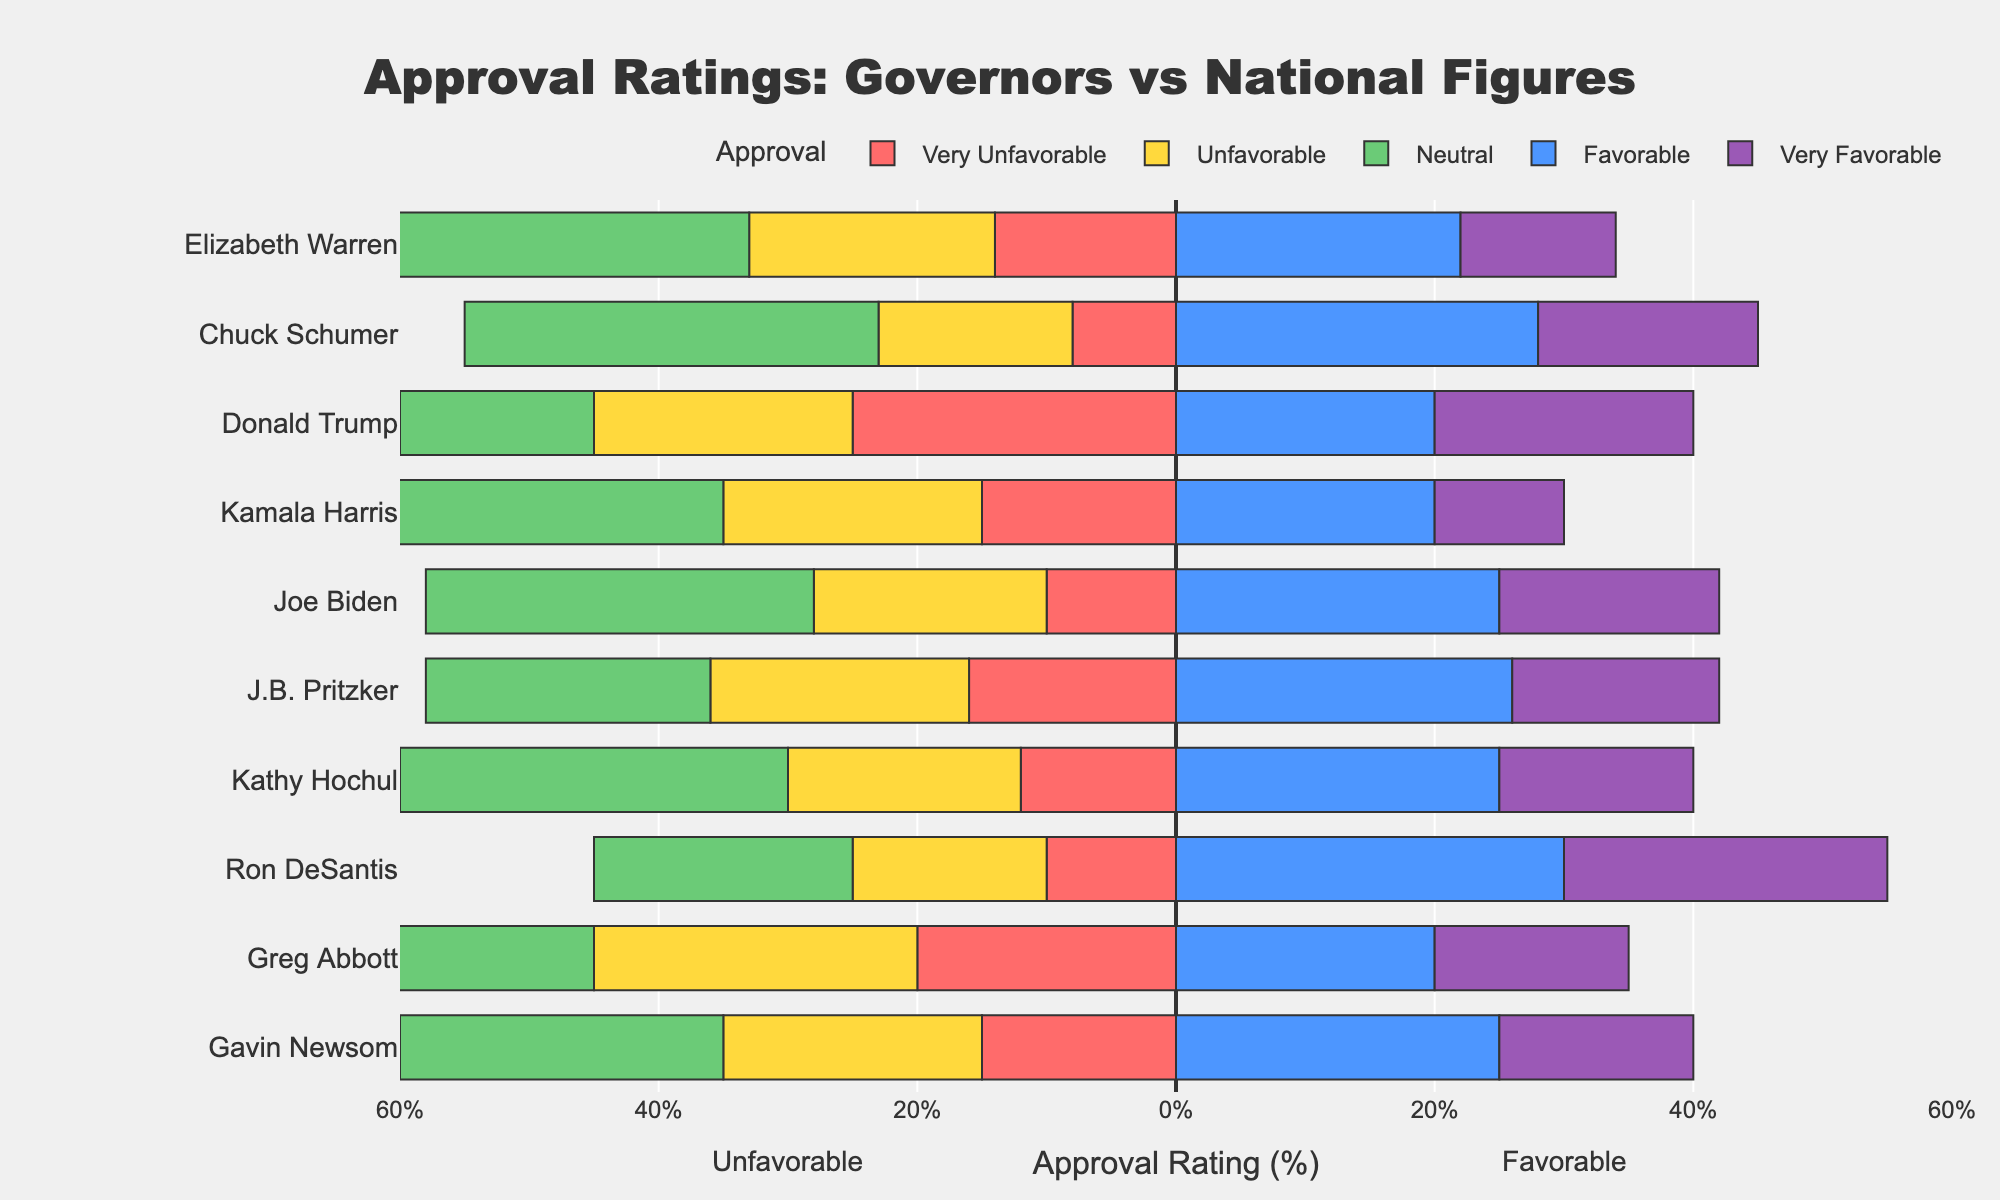What is the difference in the percentage of very favorable approvals between Gavin Newsom and Joe Biden? Gavin Newsom has a very favorable approval rating of 15%, while Joe Biden has a very favorable approval rating of 17%. The difference is calculated as 17% - 15%.
Answer: 2% Which governor has the highest unfavorable approval rating? By comparing all the governors' unfavorable approval ratings, Greg Abbott has an unfavorable rating of 25%, which is the highest among the governors listed.
Answer: Greg Abbott For Ron DeSantis, what is the total percentage of combined favorable (favorable + very favorable) approvals? How does it compare to Donald Trump's combined favorable approvals? Ron DeSantis has favorable and very favorable ratings at 30% and 25%, respectively, summing up to 30 + 25 = 55%. Donald Trump has 20% favorable and 20% very favorable, summing up to 20 + 20 = 40%. Therefore, Ron DeSantis has 15% more combined favorable approvals than Donald Trump.
Answer: 55% for Ron DeSantis, 15% more than Donald Trump What is the neutral approval rating for Kamala Harris, and how does it compare to Greg Abbott's neutral rating? Kamala Harris has a neutral rating of 35%, while Greg Abbott has a neutral rating of 20%. The difference between them is 35% - 20%.
Answer: 15% higher for Kamala Harris Between Kathy Hochul and Elizabeth Warren, who has the higher total of very unfavorable and unfavorable approval ratings, and by how much? Kathy Hochul's very unfavorable and unfavorable ratings are 12% and 18%, respectively, totaling 12 + 18 = 30%. Elizabeth Warren's very unfavorable and unfavorable ratings are 14% and 19%, totaling 14 + 19 = 33%. Thus, Elizabeth Warren has a higher total by 33% - 30%.
Answer: Elizabeth Warren by 3% What are the percentages of neutral approval for governors compared to national figures in New York and Illinois? Kathy Hochul in New York has a 30% neutral rating, while Chuck Schumer has a 32% neutral rating. In Illinois, J.B. Pritzker has a 22% neutral rating, and Elizabeth Warren has a 33% neutral rating.
Answer: New York: 30% vs. 32%, Illinois: 22% vs. 33% In which province does the governor have a higher very favorable rating than the corresponding national figure, and what is the difference? Ron DeSantis in Florida has a very favorable rating of 25%, while Donald Trump has 20%, resulting in a difference of 25 - 20 = 5%.
Answer: Florida by 5% Which figure, governor or national, has the smallest neutral approval percentage and what is it? Ron DeSantis has the smallest neutral approval percentage among governors with 20%. Among national figures, Donald Trump has the smallest neutral percentage with 15%.
Answer: Donald Trump with 15% Compare the favorable approval ratings of Gavin Newsom and Joe Biden. Is there a significant difference? Gavin Newsom and Joe Biden both have favorable approval ratings of 25%, indicating no significant difference between them.
Answer: No difference How do Greg Abbott's unfavorable and very unfavorable ratings compare to Kamala Harris's corresponding ratings? Which one has higher combined unfavorable ratings and by how much? Greg Abbott has unfavorable and very unfavorable ratings of 25% and 20%, totaling 25 + 20 = 45%. Kamala Harris has 20% unfavorable and 15% very unfavorable, totaling 20 + 15 = 35%. Thus, Greg Abbott has higher combined unfavorable ratings by 45 - 35 = 10%.
Answer: Greg Abbott by 10% 